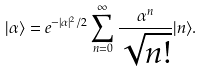<formula> <loc_0><loc_0><loc_500><loc_500>| \alpha \rangle = e ^ { - | \alpha | ^ { 2 } / 2 } \sum _ { n = 0 } ^ { \infty } { \frac { \alpha ^ { n } } { \sqrt { n ! } } } | n \rangle .</formula> 